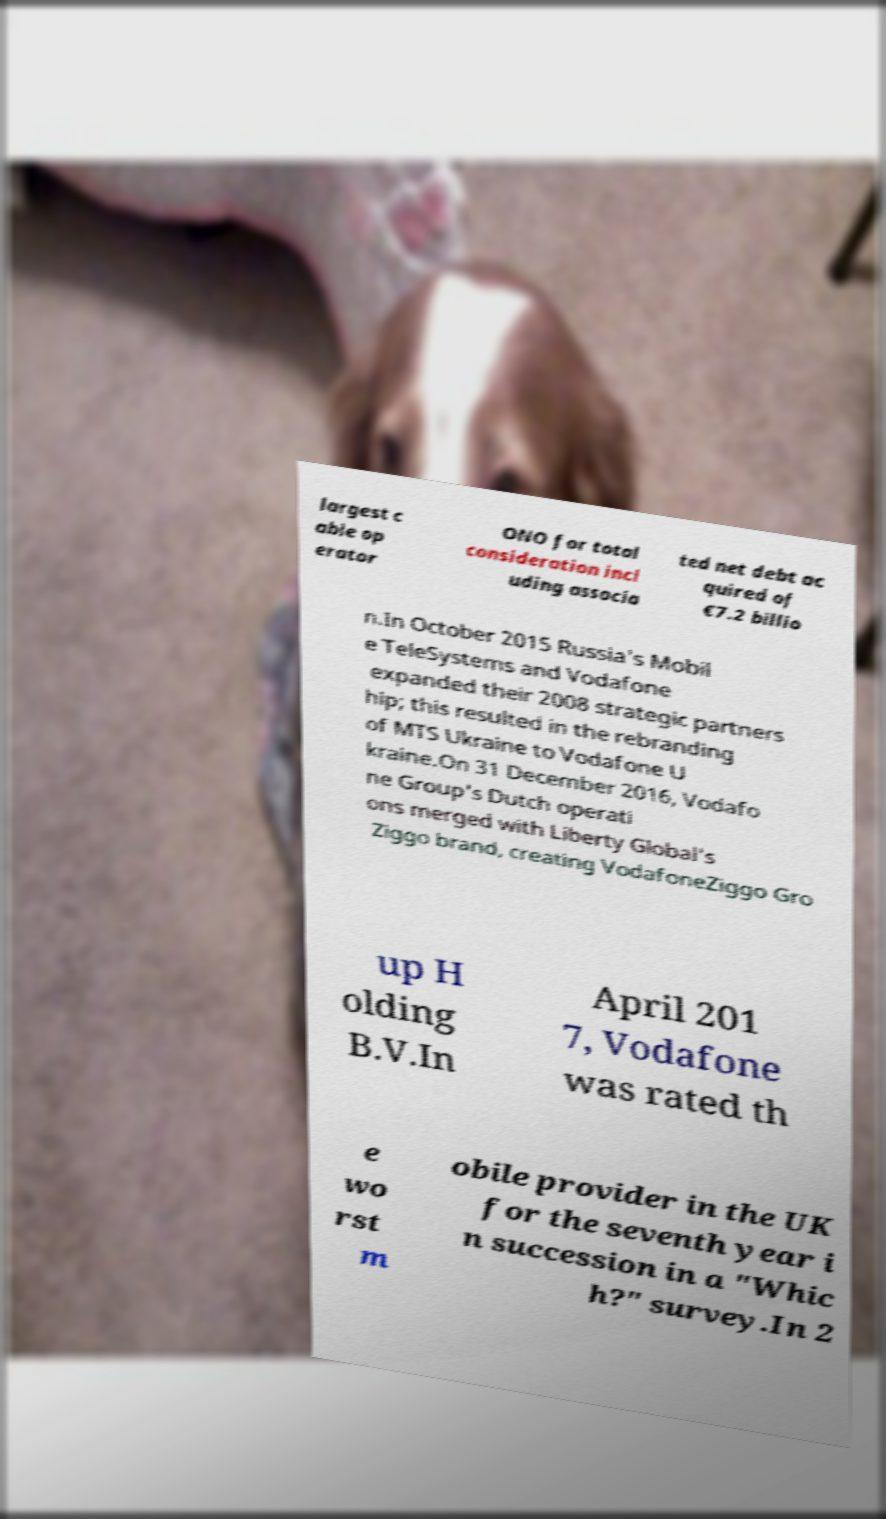I need the written content from this picture converted into text. Can you do that? largest c able op erator ONO for total consideration incl uding associa ted net debt ac quired of €7.2 billio n.In October 2015 Russia's Mobil e TeleSystems and Vodafone expanded their 2008 strategic partners hip; this resulted in the rebranding of MTS Ukraine to Vodafone U kraine.On 31 December 2016, Vodafo ne Group's Dutch operati ons merged with Liberty Global's Ziggo brand, creating VodafoneZiggo Gro up H olding B.V.In April 201 7, Vodafone was rated th e wo rst m obile provider in the UK for the seventh year i n succession in a "Whic h?" survey.In 2 